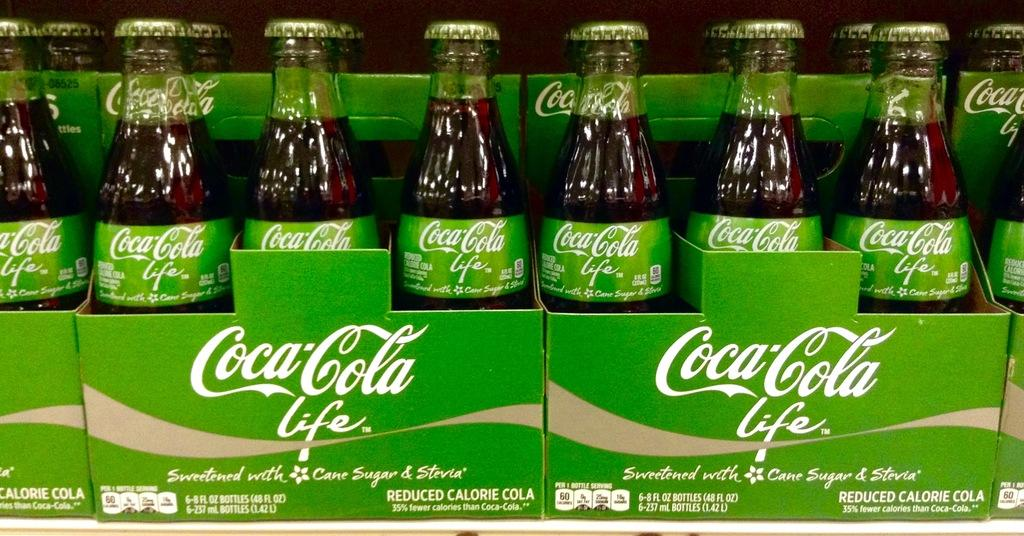<image>
Render a clear and concise summary of the photo. Several bottles of Coca Cola sitting side by side in cardboard containers. 